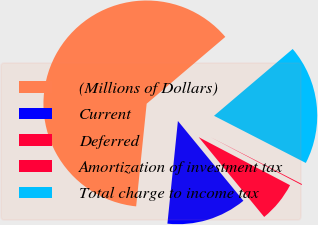Convert chart. <chart><loc_0><loc_0><loc_500><loc_500><pie_chart><fcel>(Millions of Dollars)<fcel>Current<fcel>Deferred<fcel>Amortization of investment tax<fcel>Total charge to income tax<nl><fcel>62.17%<fcel>12.56%<fcel>6.36%<fcel>0.15%<fcel>18.76%<nl></chart> 